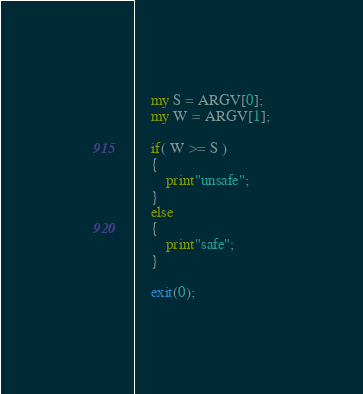Convert code to text. <code><loc_0><loc_0><loc_500><loc_500><_Perl_>    my S = ARGV[0];
    my W = ARGV[1];
     
    if( W >= S )
    {
    	print"unsafe";
    }
    else
    {
    	print"safe";
    }
     
    exit(0);</code> 